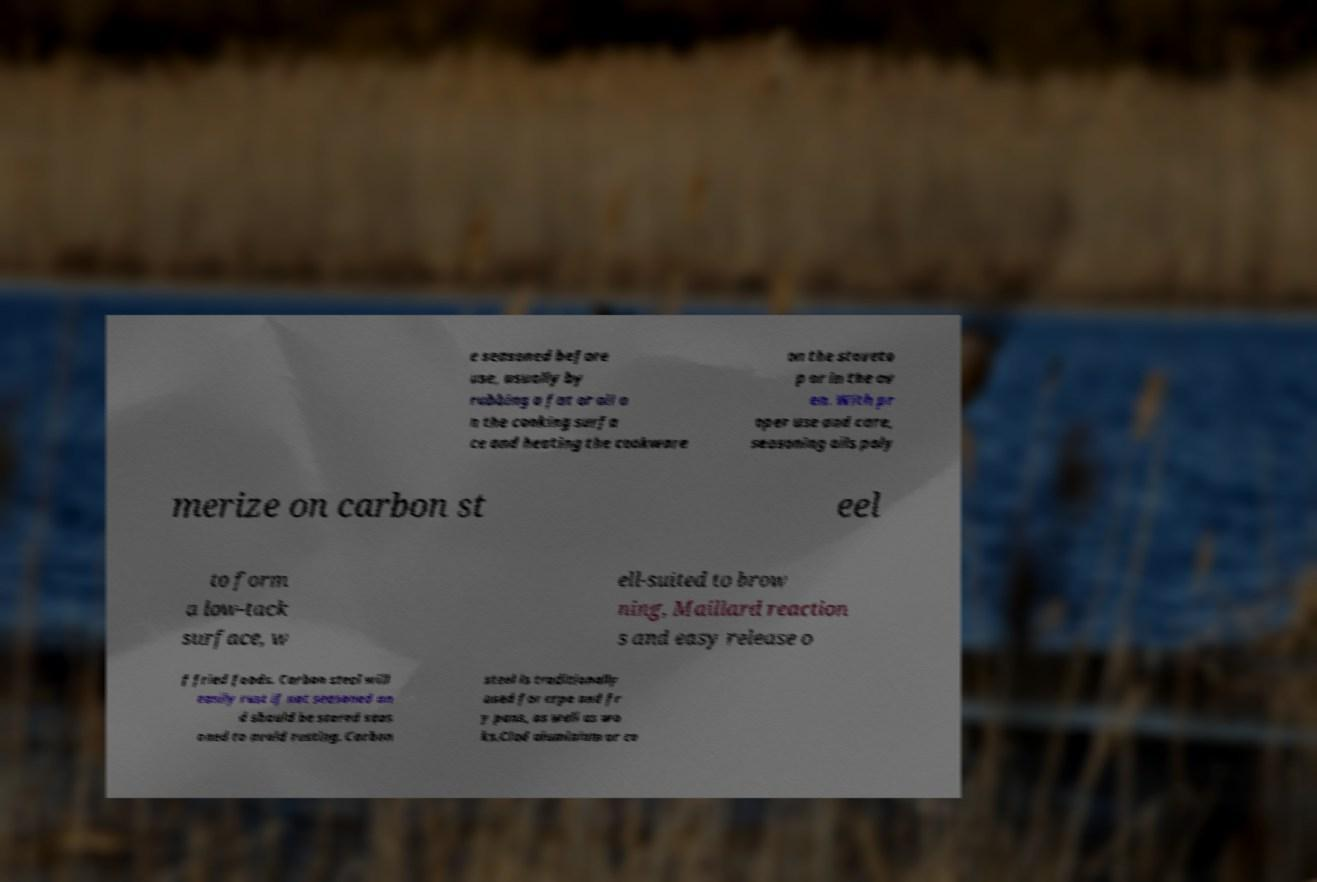Can you read and provide the text displayed in the image?This photo seems to have some interesting text. Can you extract and type it out for me? e seasoned before use, usually by rubbing a fat or oil o n the cooking surfa ce and heating the cookware on the stoveto p or in the ov en. With pr oper use and care, seasoning oils poly merize on carbon st eel to form a low-tack surface, w ell-suited to brow ning, Maillard reaction s and easy release o f fried foods. Carbon steel will easily rust if not seasoned an d should be stored seas oned to avoid rusting. Carbon steel is traditionally used for crpe and fr y pans, as well as wo ks.Clad aluminium or co 